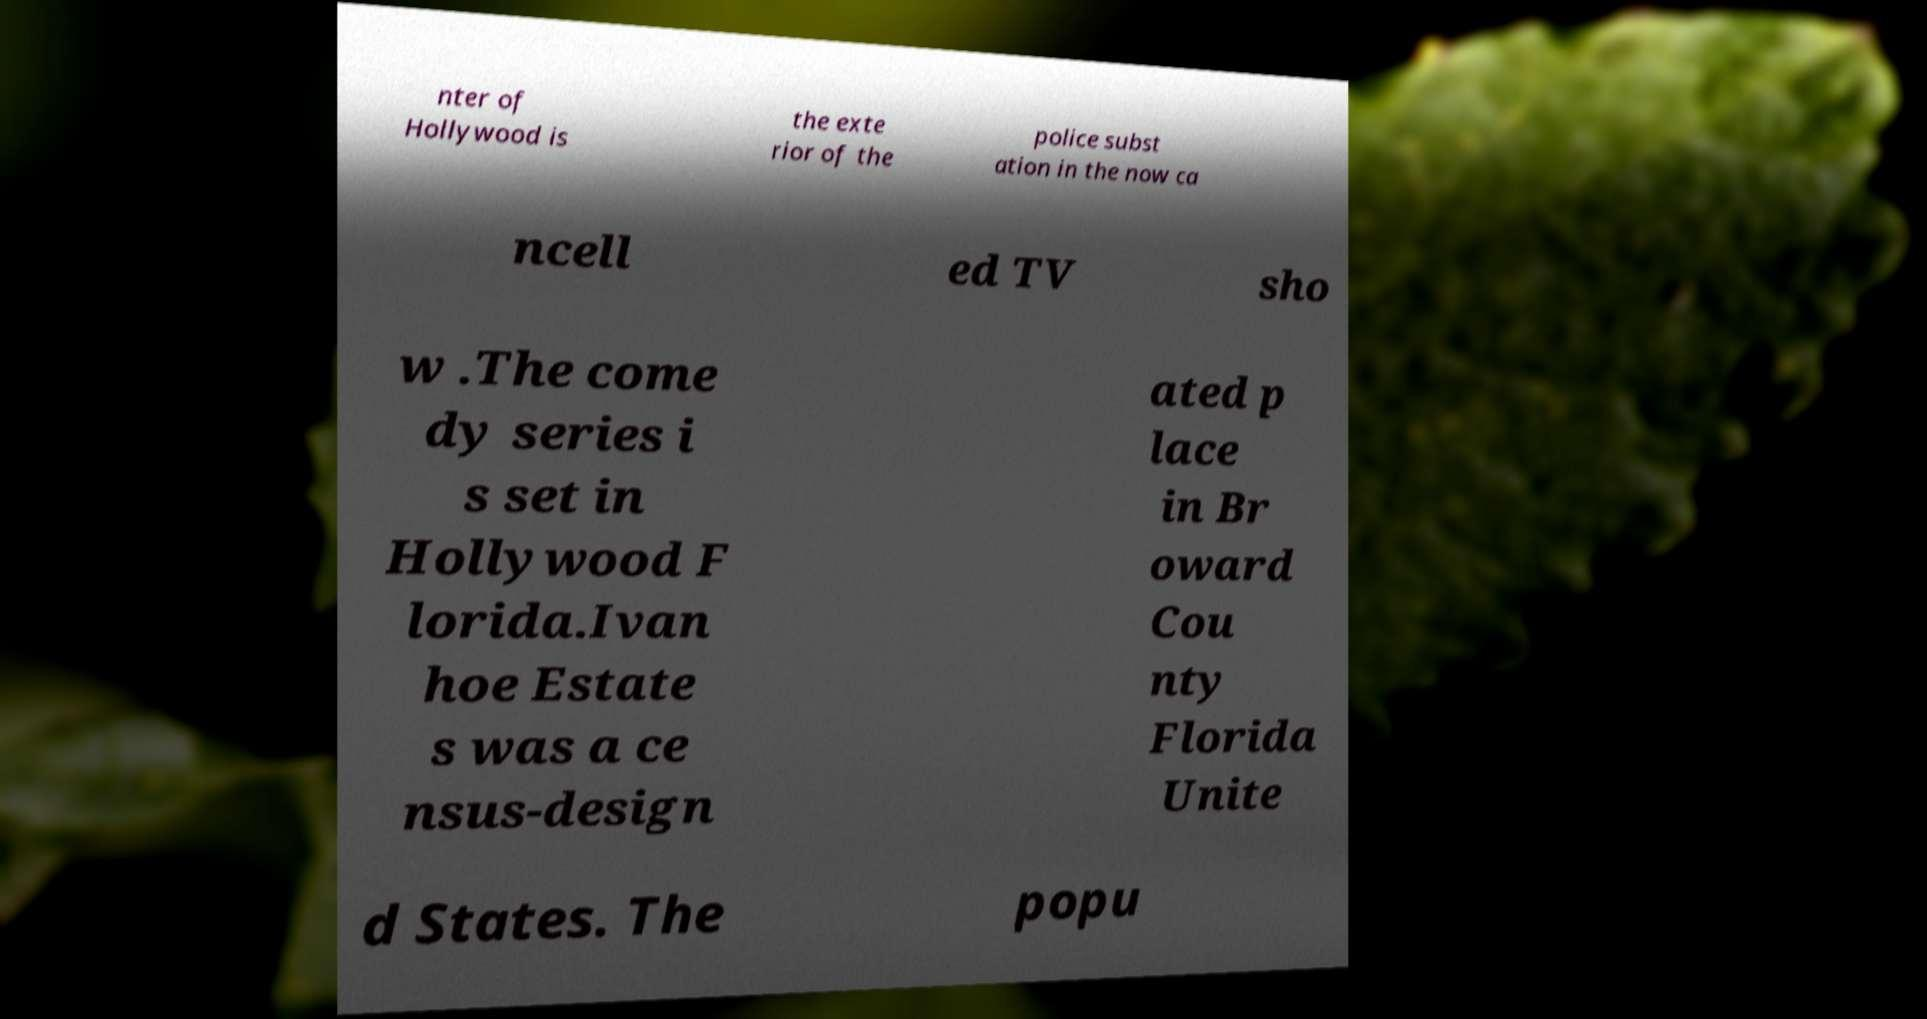Can you accurately transcribe the text from the provided image for me? nter of Hollywood is the exte rior of the police subst ation in the now ca ncell ed TV sho w .The come dy series i s set in Hollywood F lorida.Ivan hoe Estate s was a ce nsus-design ated p lace in Br oward Cou nty Florida Unite d States. The popu 